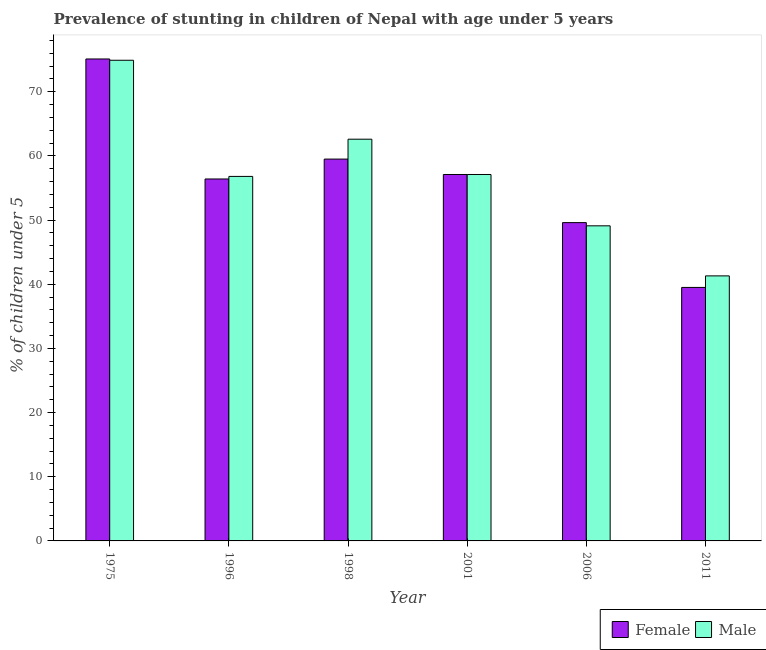How many different coloured bars are there?
Offer a very short reply. 2. Are the number of bars on each tick of the X-axis equal?
Ensure brevity in your answer.  Yes. How many bars are there on the 2nd tick from the left?
Provide a succinct answer. 2. How many bars are there on the 3rd tick from the right?
Offer a very short reply. 2. What is the label of the 4th group of bars from the left?
Ensure brevity in your answer.  2001. What is the percentage of stunted male children in 2001?
Your answer should be compact. 57.1. Across all years, what is the maximum percentage of stunted male children?
Your response must be concise. 74.9. Across all years, what is the minimum percentage of stunted male children?
Your answer should be compact. 41.3. In which year was the percentage of stunted male children maximum?
Ensure brevity in your answer.  1975. What is the total percentage of stunted male children in the graph?
Keep it short and to the point. 341.8. What is the difference between the percentage of stunted male children in 1975 and that in 2006?
Provide a succinct answer. 25.8. What is the difference between the percentage of stunted male children in 2011 and the percentage of stunted female children in 1996?
Provide a succinct answer. -15.5. What is the average percentage of stunted male children per year?
Ensure brevity in your answer.  56.97. In the year 1975, what is the difference between the percentage of stunted male children and percentage of stunted female children?
Offer a terse response. 0. In how many years, is the percentage of stunted male children greater than 74 %?
Make the answer very short. 1. What is the ratio of the percentage of stunted male children in 1998 to that in 2001?
Your answer should be very brief. 1.1. What is the difference between the highest and the second highest percentage of stunted male children?
Your response must be concise. 12.3. What is the difference between the highest and the lowest percentage of stunted male children?
Offer a terse response. 33.6. In how many years, is the percentage of stunted male children greater than the average percentage of stunted male children taken over all years?
Your answer should be compact. 3. Are all the bars in the graph horizontal?
Give a very brief answer. No. Does the graph contain grids?
Offer a very short reply. No. Where does the legend appear in the graph?
Provide a succinct answer. Bottom right. What is the title of the graph?
Offer a terse response. Prevalence of stunting in children of Nepal with age under 5 years. Does "Gasoline" appear as one of the legend labels in the graph?
Offer a terse response. No. What is the label or title of the X-axis?
Ensure brevity in your answer.  Year. What is the label or title of the Y-axis?
Offer a very short reply.  % of children under 5. What is the  % of children under 5 of Female in 1975?
Give a very brief answer. 75.1. What is the  % of children under 5 in Male in 1975?
Ensure brevity in your answer.  74.9. What is the  % of children under 5 of Female in 1996?
Make the answer very short. 56.4. What is the  % of children under 5 in Male in 1996?
Make the answer very short. 56.8. What is the  % of children under 5 of Female in 1998?
Your answer should be very brief. 59.5. What is the  % of children under 5 of Male in 1998?
Your response must be concise. 62.6. What is the  % of children under 5 in Female in 2001?
Your answer should be compact. 57.1. What is the  % of children under 5 in Male in 2001?
Provide a short and direct response. 57.1. What is the  % of children under 5 in Female in 2006?
Provide a short and direct response. 49.6. What is the  % of children under 5 in Male in 2006?
Your answer should be compact. 49.1. What is the  % of children under 5 of Female in 2011?
Your answer should be very brief. 39.5. What is the  % of children under 5 of Male in 2011?
Offer a terse response. 41.3. Across all years, what is the maximum  % of children under 5 of Female?
Give a very brief answer. 75.1. Across all years, what is the maximum  % of children under 5 in Male?
Provide a short and direct response. 74.9. Across all years, what is the minimum  % of children under 5 of Female?
Ensure brevity in your answer.  39.5. Across all years, what is the minimum  % of children under 5 in Male?
Offer a very short reply. 41.3. What is the total  % of children under 5 in Female in the graph?
Your answer should be very brief. 337.2. What is the total  % of children under 5 of Male in the graph?
Provide a succinct answer. 341.8. What is the difference between the  % of children under 5 in Female in 1975 and that in 1996?
Provide a short and direct response. 18.7. What is the difference between the  % of children under 5 in Male in 1975 and that in 1998?
Provide a succinct answer. 12.3. What is the difference between the  % of children under 5 of Female in 1975 and that in 2001?
Make the answer very short. 18. What is the difference between the  % of children under 5 of Male in 1975 and that in 2006?
Provide a succinct answer. 25.8. What is the difference between the  % of children under 5 in Female in 1975 and that in 2011?
Ensure brevity in your answer.  35.6. What is the difference between the  % of children under 5 in Male in 1975 and that in 2011?
Provide a short and direct response. 33.6. What is the difference between the  % of children under 5 in Male in 1996 and that in 2006?
Make the answer very short. 7.7. What is the difference between the  % of children under 5 in Male in 1996 and that in 2011?
Offer a terse response. 15.5. What is the difference between the  % of children under 5 of Male in 1998 and that in 2006?
Provide a short and direct response. 13.5. What is the difference between the  % of children under 5 in Male in 1998 and that in 2011?
Give a very brief answer. 21.3. What is the difference between the  % of children under 5 in Female in 2001 and that in 2006?
Offer a very short reply. 7.5. What is the difference between the  % of children under 5 of Male in 2001 and that in 2006?
Your response must be concise. 8. What is the difference between the  % of children under 5 in Female in 2001 and that in 2011?
Offer a very short reply. 17.6. What is the difference between the  % of children under 5 of Male in 2006 and that in 2011?
Provide a short and direct response. 7.8. What is the difference between the  % of children under 5 in Female in 1975 and the  % of children under 5 in Male in 1996?
Your answer should be very brief. 18.3. What is the difference between the  % of children under 5 in Female in 1975 and the  % of children under 5 in Male in 1998?
Your answer should be compact. 12.5. What is the difference between the  % of children under 5 in Female in 1975 and the  % of children under 5 in Male in 2006?
Give a very brief answer. 26. What is the difference between the  % of children under 5 in Female in 1975 and the  % of children under 5 in Male in 2011?
Ensure brevity in your answer.  33.8. What is the difference between the  % of children under 5 in Female in 1996 and the  % of children under 5 in Male in 2006?
Keep it short and to the point. 7.3. What is the difference between the  % of children under 5 in Female in 1996 and the  % of children under 5 in Male in 2011?
Offer a very short reply. 15.1. What is the difference between the  % of children under 5 in Female in 1998 and the  % of children under 5 in Male in 2011?
Ensure brevity in your answer.  18.2. What is the difference between the  % of children under 5 of Female in 2001 and the  % of children under 5 of Male in 2011?
Keep it short and to the point. 15.8. What is the average  % of children under 5 of Female per year?
Offer a terse response. 56.2. What is the average  % of children under 5 in Male per year?
Offer a terse response. 56.97. In the year 1996, what is the difference between the  % of children under 5 in Female and  % of children under 5 in Male?
Offer a very short reply. -0.4. In the year 2001, what is the difference between the  % of children under 5 of Female and  % of children under 5 of Male?
Your response must be concise. 0. What is the ratio of the  % of children under 5 of Female in 1975 to that in 1996?
Keep it short and to the point. 1.33. What is the ratio of the  % of children under 5 of Male in 1975 to that in 1996?
Provide a succinct answer. 1.32. What is the ratio of the  % of children under 5 in Female in 1975 to that in 1998?
Offer a terse response. 1.26. What is the ratio of the  % of children under 5 of Male in 1975 to that in 1998?
Provide a short and direct response. 1.2. What is the ratio of the  % of children under 5 in Female in 1975 to that in 2001?
Give a very brief answer. 1.32. What is the ratio of the  % of children under 5 in Male in 1975 to that in 2001?
Provide a short and direct response. 1.31. What is the ratio of the  % of children under 5 of Female in 1975 to that in 2006?
Give a very brief answer. 1.51. What is the ratio of the  % of children under 5 in Male in 1975 to that in 2006?
Provide a succinct answer. 1.53. What is the ratio of the  % of children under 5 in Female in 1975 to that in 2011?
Your answer should be very brief. 1.9. What is the ratio of the  % of children under 5 of Male in 1975 to that in 2011?
Give a very brief answer. 1.81. What is the ratio of the  % of children under 5 of Female in 1996 to that in 1998?
Offer a terse response. 0.95. What is the ratio of the  % of children under 5 of Male in 1996 to that in 1998?
Make the answer very short. 0.91. What is the ratio of the  % of children under 5 of Female in 1996 to that in 2006?
Offer a very short reply. 1.14. What is the ratio of the  % of children under 5 in Male in 1996 to that in 2006?
Keep it short and to the point. 1.16. What is the ratio of the  % of children under 5 in Female in 1996 to that in 2011?
Provide a short and direct response. 1.43. What is the ratio of the  % of children under 5 of Male in 1996 to that in 2011?
Your answer should be very brief. 1.38. What is the ratio of the  % of children under 5 of Female in 1998 to that in 2001?
Your answer should be very brief. 1.04. What is the ratio of the  % of children under 5 in Male in 1998 to that in 2001?
Make the answer very short. 1.1. What is the ratio of the  % of children under 5 of Female in 1998 to that in 2006?
Make the answer very short. 1.2. What is the ratio of the  % of children under 5 in Male in 1998 to that in 2006?
Your answer should be very brief. 1.27. What is the ratio of the  % of children under 5 of Female in 1998 to that in 2011?
Your response must be concise. 1.51. What is the ratio of the  % of children under 5 of Male in 1998 to that in 2011?
Ensure brevity in your answer.  1.52. What is the ratio of the  % of children under 5 in Female in 2001 to that in 2006?
Your response must be concise. 1.15. What is the ratio of the  % of children under 5 in Male in 2001 to that in 2006?
Your response must be concise. 1.16. What is the ratio of the  % of children under 5 of Female in 2001 to that in 2011?
Your answer should be compact. 1.45. What is the ratio of the  % of children under 5 of Male in 2001 to that in 2011?
Offer a very short reply. 1.38. What is the ratio of the  % of children under 5 in Female in 2006 to that in 2011?
Provide a succinct answer. 1.26. What is the ratio of the  % of children under 5 in Male in 2006 to that in 2011?
Keep it short and to the point. 1.19. What is the difference between the highest and the second highest  % of children under 5 of Female?
Your answer should be very brief. 15.6. What is the difference between the highest and the second highest  % of children under 5 in Male?
Your answer should be very brief. 12.3. What is the difference between the highest and the lowest  % of children under 5 of Female?
Provide a succinct answer. 35.6. What is the difference between the highest and the lowest  % of children under 5 in Male?
Provide a succinct answer. 33.6. 